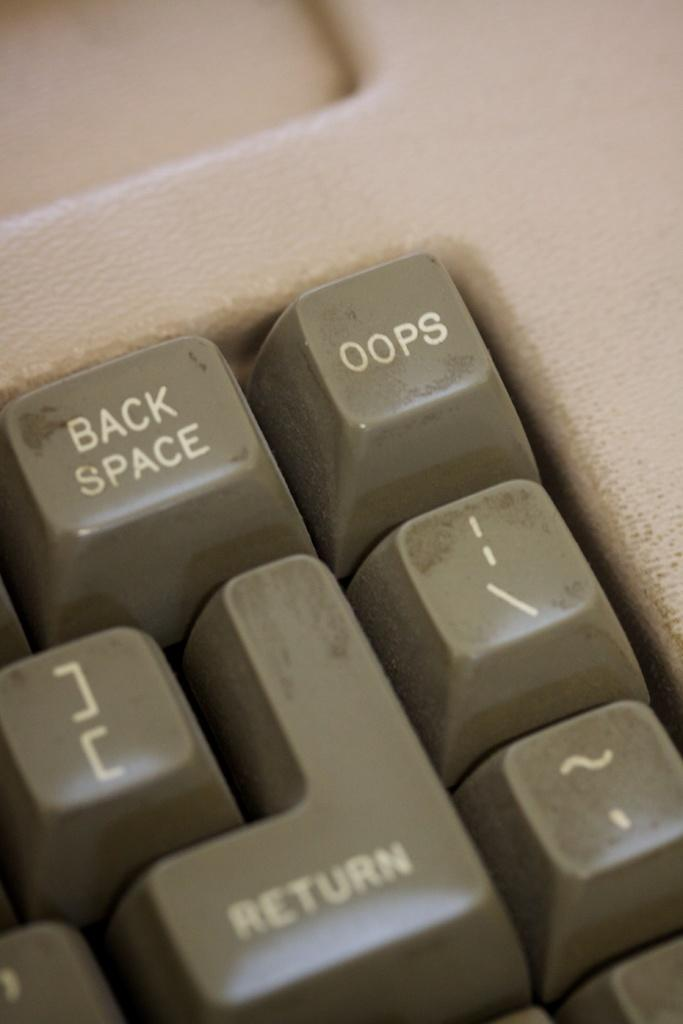<image>
Present a compact description of the photo's key features. The oops key is located to the right of the back space key on the keyboard being displayed. 